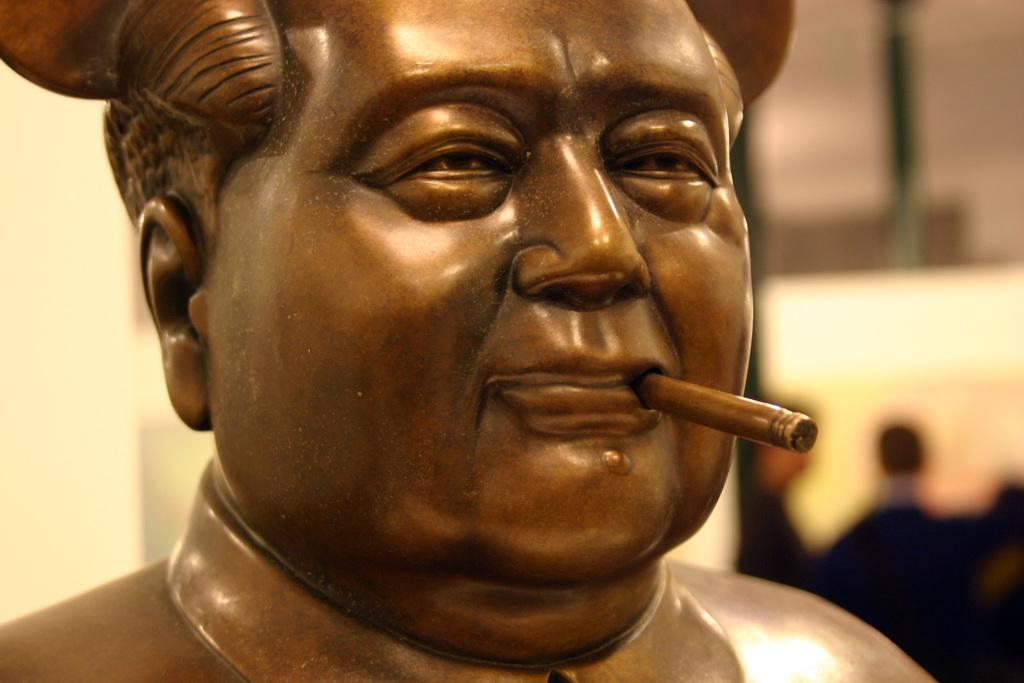What is the main subject of the image? There is a sculpture in the image. Can you describe the background of the image? The background of the image is blurred. What type of birthday celebration is depicted in the image? There is no birthday celebration present in the image; it features a sculpture with a blurred background. What is the condition of the crate in the image? There is no crate present in the image. What is the color of the wristband in the image? There is no wristband present in the image. 